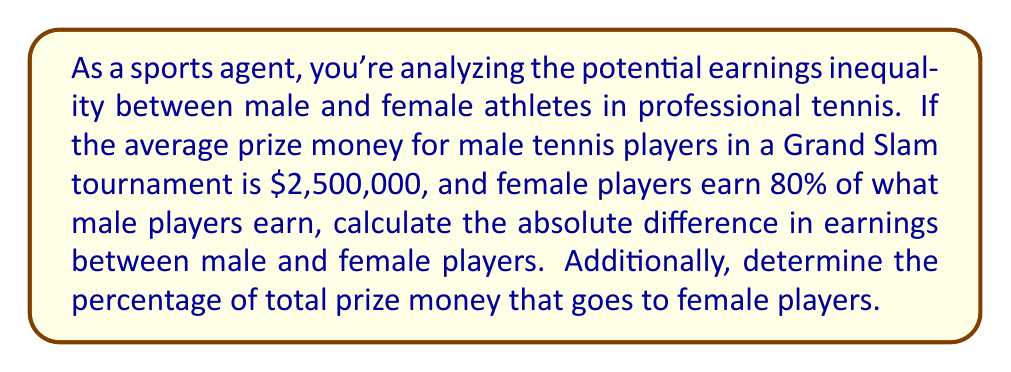Could you help me with this problem? Let's approach this step-by-step:

1. Calculate the average prize money for female players:
   Female earnings = 80% of male earnings
   $$ \text{Female earnings} = 0.80 \times \$2,500,000 = \$2,000,000 $$

2. Calculate the absolute difference in earnings:
   $$ \text{Difference} = \text{Male earnings} - \text{Female earnings} $$
   $$ \text{Difference} = \$2,500,000 - \$2,000,000 = \$500,000 $$

3. Calculate the total prize money:
   $$ \text{Total} = \text{Male earnings} + \text{Female earnings} $$
   $$ \text{Total} = \$2,500,000 + \$2,000,000 = \$4,500,000 $$

4. Calculate the percentage of total prize money that goes to female players:
   $$ \text{Female percentage} = \frac{\text{Female earnings}}{\text{Total}} \times 100\% $$
   $$ \text{Female percentage} = \frac{\$2,000,000}{\$4,500,000} \times 100\% = 44.44\% $$
Answer: $500,000; 44.44% 